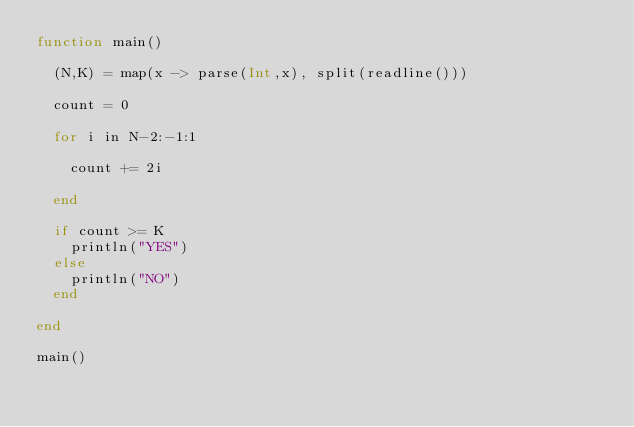Convert code to text. <code><loc_0><loc_0><loc_500><loc_500><_Julia_>function main()
  
  (N,K) = map(x -> parse(Int,x), split(readline()))
  
  count = 0
  
  for i in N-2:-1:1
    
    count += 2i
    
  end
  
  if count >= K
    println("YES")
  else
    println("NO")
  end
  
end

main()</code> 